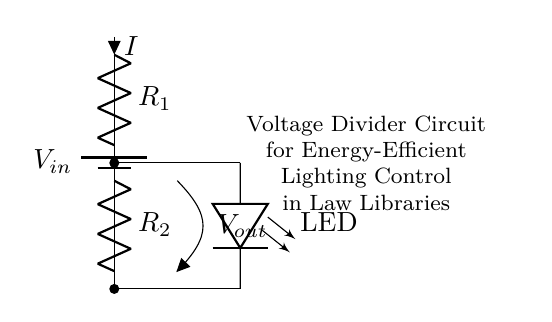What does the circuit provide to the LED? The circuit provides a low voltage output suitable for the LED, which is derived from the voltage divider effect of resistors R1 and R2. The resistors divide the input voltage, allowing a correct enough voltage through the LED for illumination.
Answer: low voltage What are the components of this voltage divider circuit? The components of the circuit are a battery (power source), two resistors (R1 and R2), and an LED. The resistors are connected in series and are responsible for dividing the input voltage, while the LED shows the output of this voltage division.
Answer: battery, R1, R2, LED What is the current direction through R1? The current flows downward through R1 from the battery to R2, as indicated by the arrow labeled with 'I.' This shows the path of current as it moves through the circuit components from the power supply.
Answer: downward How is the output voltage represented in this circuit? The output voltage is represented as Vout, which is taken from the junction between R1 and R2. It measures the voltage drop across R2 in relation to the ground, which is crucial for controlling the LED's brightness.
Answer: Vout If R1 is 2k ohm and R2 is 3k ohm, what is the output voltage with an input voltage of 10V? Using the voltage divider formula, Vout can be calculated as Vout = Vin * (R2 / (R1 + R2)). Substituting gives Vout = 10V * (3k / (2k + 3k)) = 6V. This voltage corresponds to the voltage that would be available at the LED for efficient operations.
Answer: 6V 